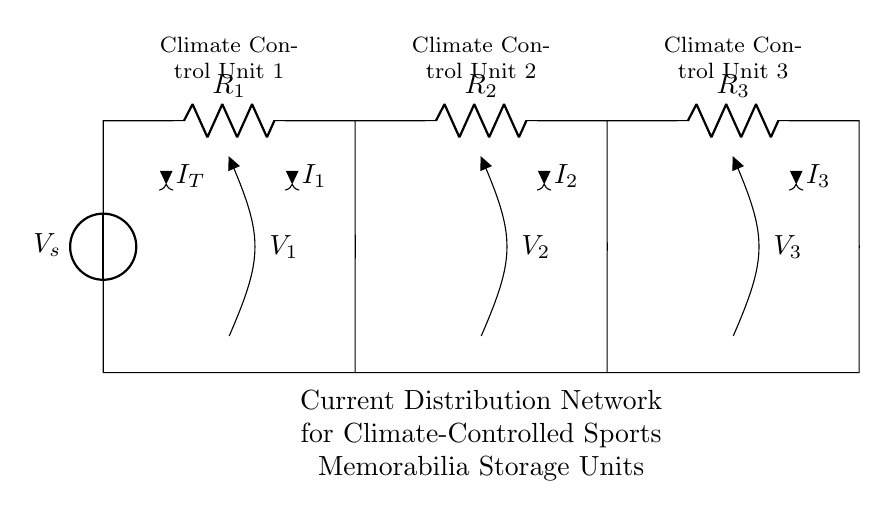What is the total current entering the circuit? The total current entering the circuit, denoted as I_T, can be identified at the voltage source, which is connected to the various resistors. It represents the sum of all individual branch currents.
Answer: I_T What type of circuit configuration is used here? The circuit configuration is a current divider, as indicated by the parallel arrangement of the resistors. This type of configuration allows the total current to split among the branches.
Answer: Current Divider How many climate control units are in the circuit? There are three climate control units connected in parallel, each associated with its own resistor. This can be seen from the labeled branches in the diagram.
Answer: Three What is the relationship between the resistors and the current through each unit? The relationship is defined by Ohm's Law and the current divider rule; the current through each resistor (I_1, I_2, I_3) is inversely proportional to its resistance when the resistors are in parallel. Specifically, lower resistance leads to higher current.
Answer: Inversely proportional What is the voltage across each climate control unit? Since all climate control units are connected in parallel, the voltage across each unit (V_1, V_2, V_3) is equal to the source voltage (V_s). This is a key feature of parallel circuits, where all branches share the same voltage.
Answer: V_s Which resistor corresponds to Climate Control Unit 2? Resistor R_2 corresponds to Climate Control Unit 2, as indicated by the labeling in the diagram. Each resistor is specifically paired with a climate control unit, making it easy to identify them.
Answer: R_2 